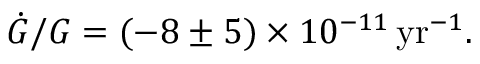<formula> <loc_0><loc_0><loc_500><loc_500>\dot { G } / G = ( - 8 \pm 5 ) \times 1 0 ^ { - 1 1 } \, y r ^ { - 1 } .</formula> 